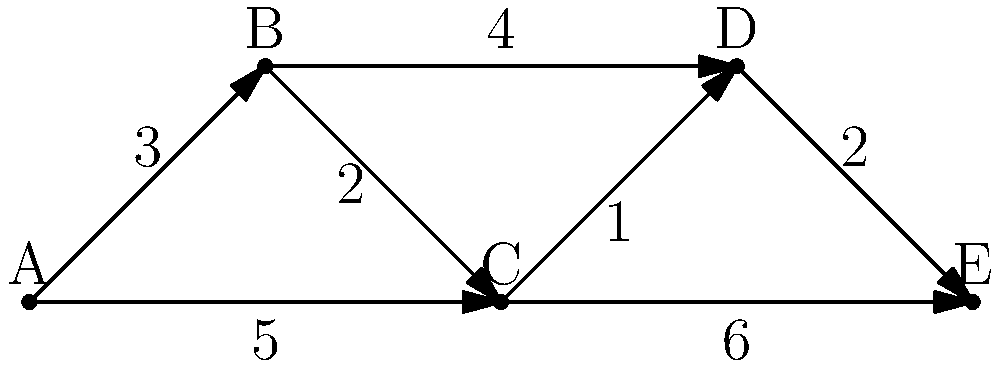In a network of drummers collaborating on heavy metal projects, each vertex represents a drummer, and each edge represents a potential collaboration, with the weight indicating the compatibility score (higher is better). What is the total compatibility score of the minimum spanning tree that connects all drummers in the most efficient way? To find the minimum spanning tree (MST) and its total weight, we can use Kruskal's algorithm:

1. Sort all edges by weight in descending order (since higher weights are better):
   CD (1), BC (2), DE (2), AB (3), BD (4), AC (5), CE (6)

2. Start with an empty MST and add edges that don't create cycles:
   - Add CD (1)
   - Add BC (2)
   - Add DE (2)
   - Add AB (3)

3. The MST is now complete with 4 edges connecting all 5 vertices.

4. Calculate the total compatibility score:
   $1 + 2 + 2 + 3 = 8$

Therefore, the total compatibility score of the minimum spanning tree is 8.
Answer: 8 